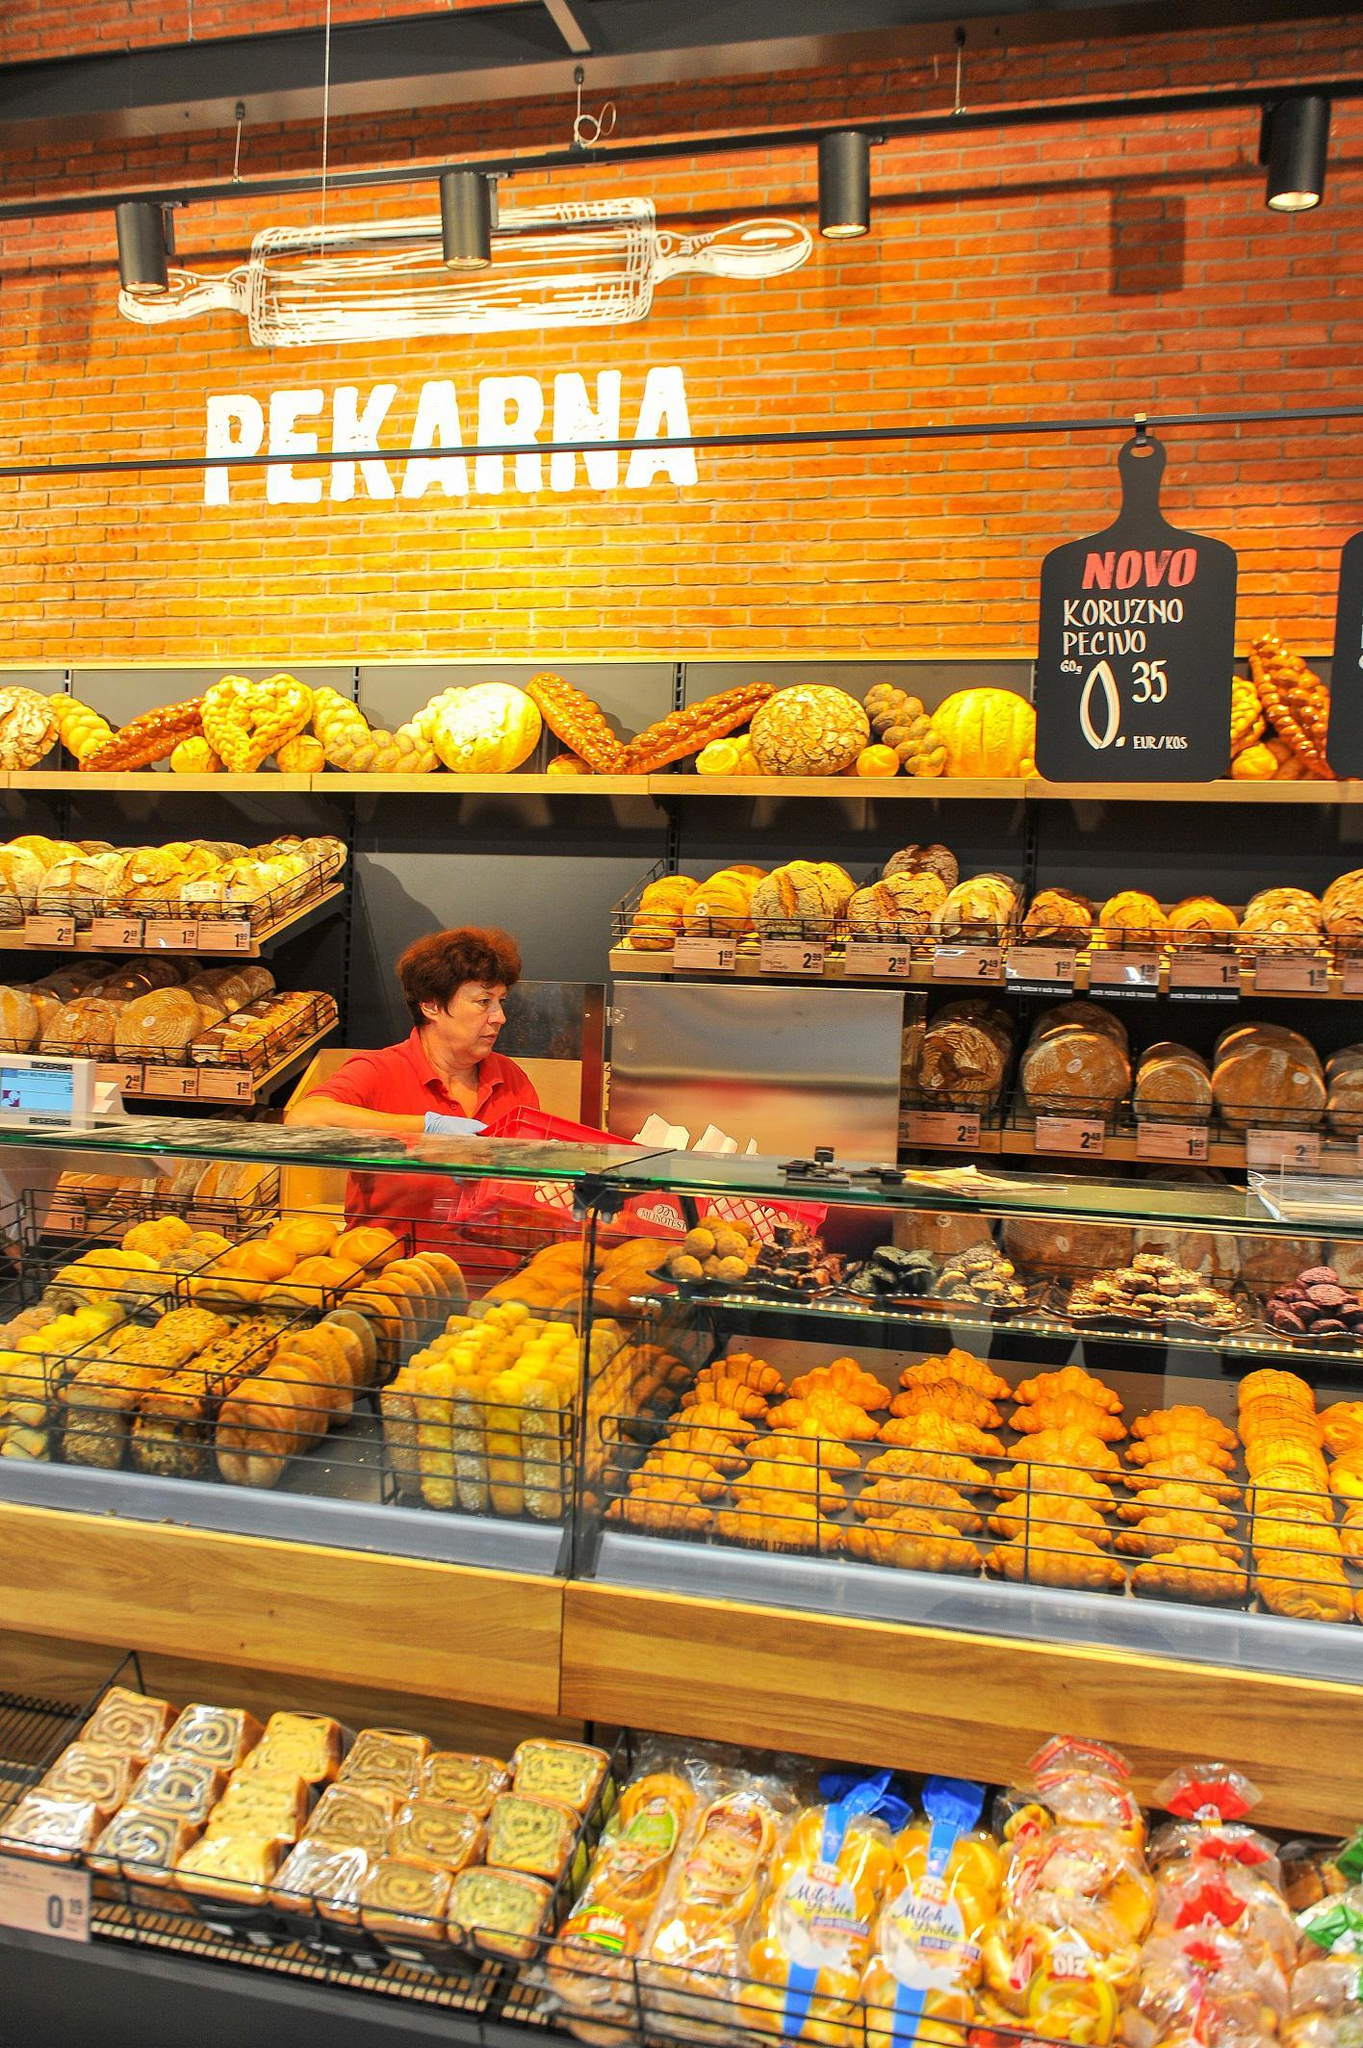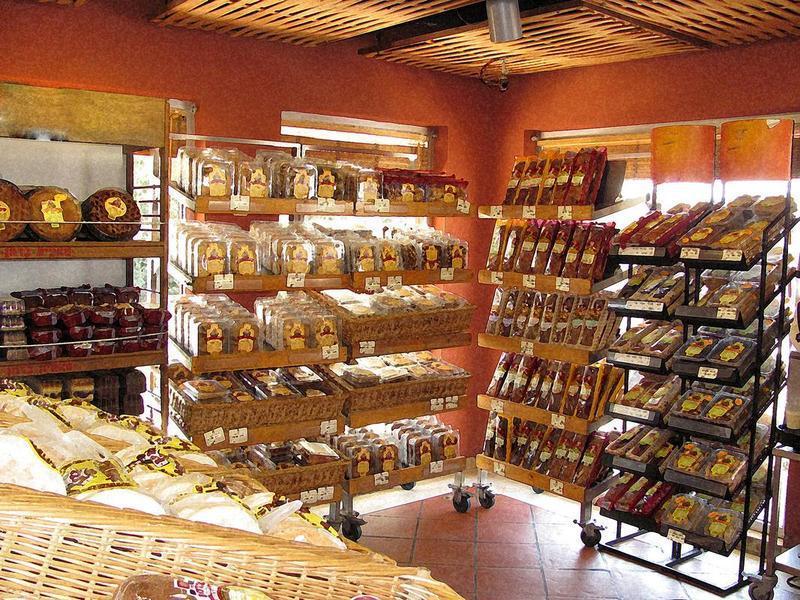The first image is the image on the left, the second image is the image on the right. Examine the images to the left and right. Is the description "A black chalkboard advertises items next to a food display in one bakery." accurate? Answer yes or no. Yes. The first image is the image on the left, the second image is the image on the right. For the images shown, is this caption "Shelves of baked goods are shown up close in both images." true? Answer yes or no. No. 